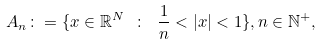<formula> <loc_0><loc_0><loc_500><loc_500>A _ { n } \colon = \{ x \in \mathbb { R } ^ { N } \ \colon \ \frac { 1 } { n } < | x | < 1 \} , n \in \mathbb { N } ^ { + } ,</formula> 